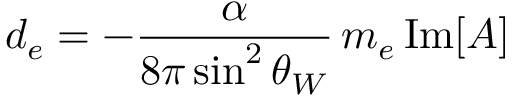Convert formula to latex. <formula><loc_0><loc_0><loc_500><loc_500>d _ { e } = - \frac { \alpha } { 8 \pi \sin ^ { 2 } \theta _ { W } } \, m _ { e } \, I m [ A ]</formula> 